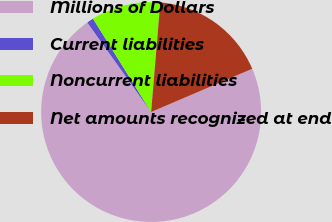<chart> <loc_0><loc_0><loc_500><loc_500><pie_chart><fcel>Millions of Dollars<fcel>Current liabilities<fcel>Noncurrent liabilities<fcel>Net amounts recognized at end<nl><fcel>71.57%<fcel>1.0%<fcel>10.19%<fcel>17.25%<nl></chart> 